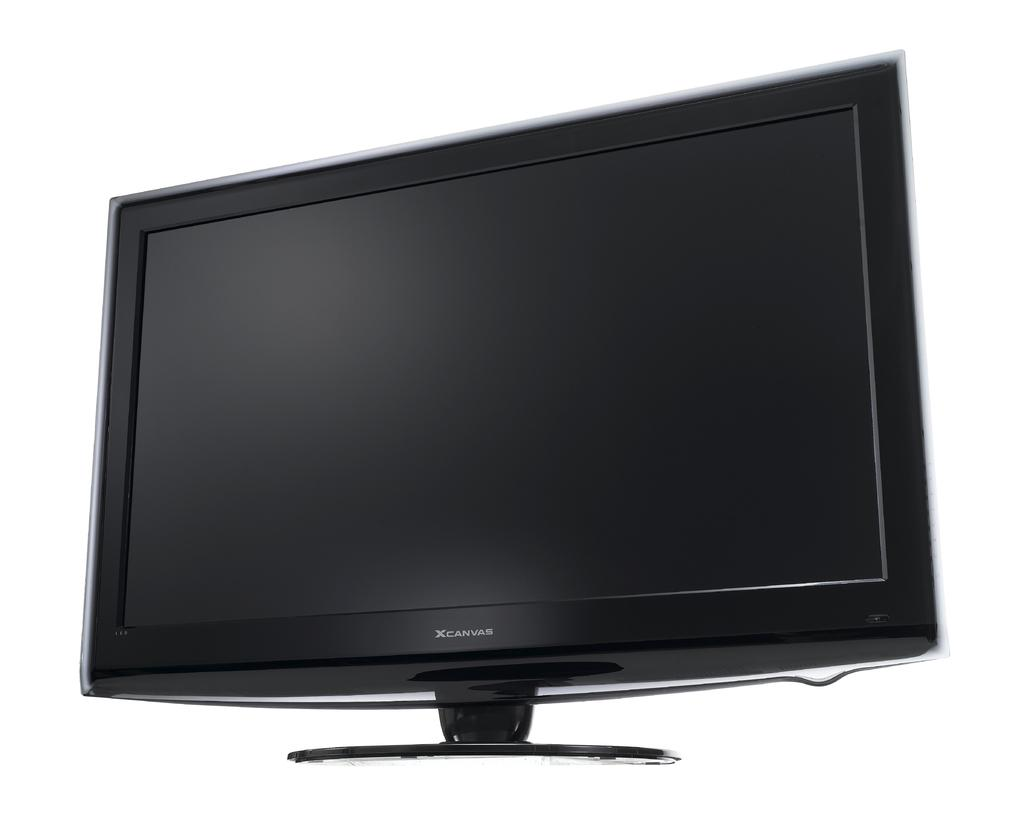<image>
Give a short and clear explanation of the subsequent image. A black XCanvas monitor sits in front of an all white background. 